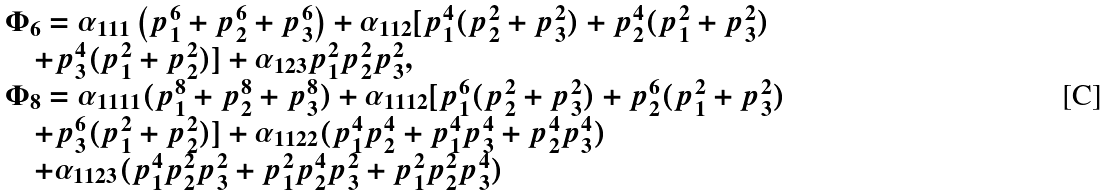<formula> <loc_0><loc_0><loc_500><loc_500>\begin{array} { l } \Phi _ { 6 } = \alpha _ { 1 1 1 } \left ( { p _ { 1 } ^ { 6 } + p _ { 2 } ^ { 6 } + p _ { 3 } ^ { 6 } } \right ) + \alpha _ { 1 1 2 } [ p _ { 1 } ^ { 4 } ( p _ { 2 } ^ { 2 } + p _ { 3 } ^ { 2 } ) + p _ { 2 } ^ { 4 } ( p _ { 1 } ^ { 2 } + p _ { 3 } ^ { 2 } ) \\ \quad + p _ { 3 } ^ { 4 } ( p _ { 1 } ^ { 2 } + p _ { 2 } ^ { 2 } ) ] + \alpha _ { 1 2 3 } p _ { 1 } ^ { 2 } p _ { 2 } ^ { 2 } p _ { 3 } ^ { 2 } , \\ \Phi _ { 8 } = \alpha _ { 1 1 1 1 } ( p _ { 1 } ^ { 8 } + p _ { 2 } ^ { 8 } + p _ { 3 } ^ { 8 } ) + \alpha _ { 1 1 1 2 } [ p _ { 1 } ^ { 6 } ( p _ { 2 } ^ { 2 } + p _ { 3 } ^ { 2 } ) + p _ { 2 } ^ { 6 } ( p _ { 1 } ^ { 2 } + p _ { 3 } ^ { 2 } ) \\ \quad + p _ { 3 } ^ { 6 } ( p _ { 1 } ^ { 2 } + p _ { 2 } ^ { 2 } ) ] + \alpha _ { 1 1 2 2 } ( p _ { 1 } ^ { 4 } p _ { 2 } ^ { 4 } + p _ { 1 } ^ { 4 } p _ { 3 } ^ { 4 } + p _ { 2 } ^ { 4 } p _ { 3 } ^ { 4 } ) \\ \quad + \alpha _ { 1 1 2 3 } ( p _ { 1 } ^ { 4 } p _ { 2 } ^ { 2 } p _ { 3 } ^ { 2 } + p _ { 1 } ^ { 2 } p _ { 2 } ^ { 4 } p _ { 3 } ^ { 2 } + p _ { 1 } ^ { 2 } p _ { 2 } ^ { 2 } p _ { 3 } ^ { 4 } ) \\ \end{array}</formula> 